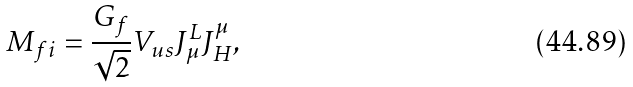Convert formula to latex. <formula><loc_0><loc_0><loc_500><loc_500>M _ { f i } = \frac { G _ { f } } { \sqrt { 2 } } V _ { u s } J _ { \mu } ^ { L } J _ { H } ^ { \mu } ,</formula> 